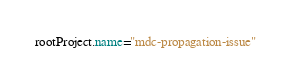Convert code to text. <code><loc_0><loc_0><loc_500><loc_500><_Kotlin_>
rootProject.name="mdc-propagation-issue"
</code> 